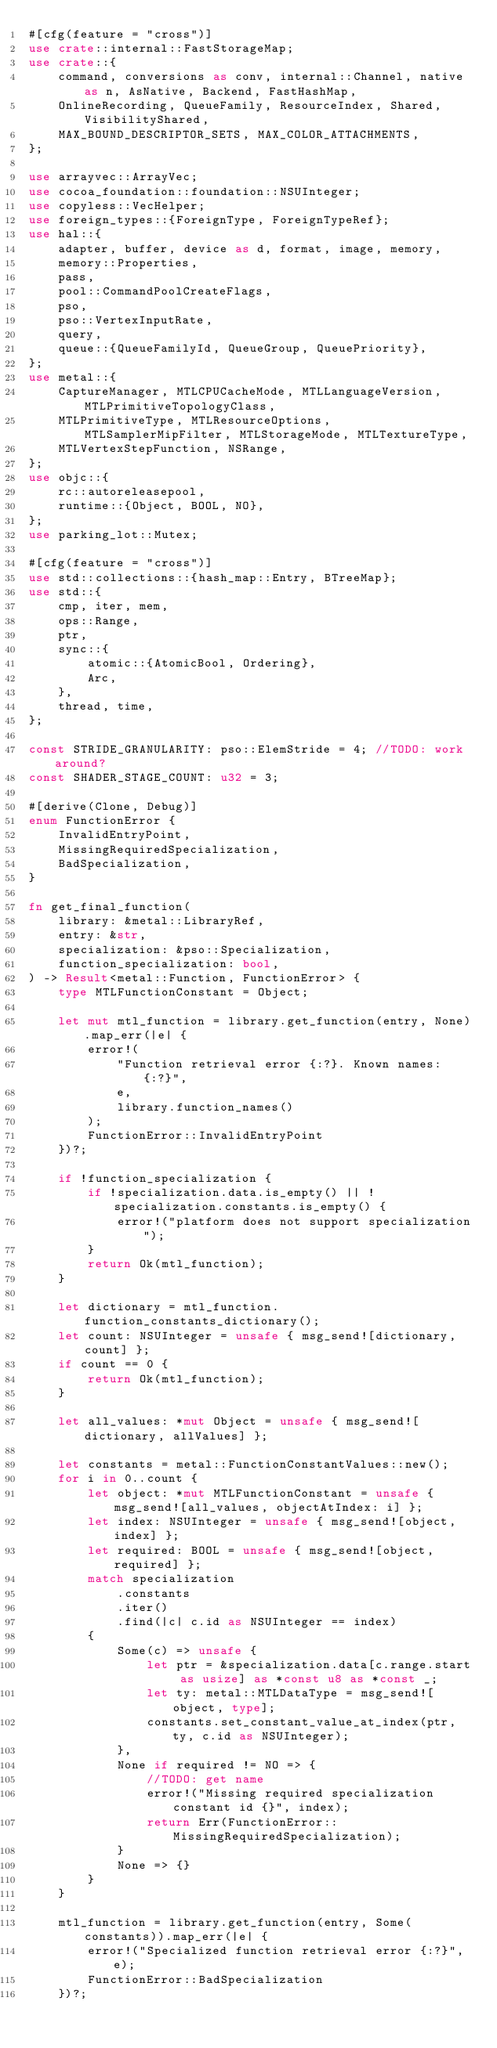<code> <loc_0><loc_0><loc_500><loc_500><_Rust_>#[cfg(feature = "cross")]
use crate::internal::FastStorageMap;
use crate::{
    command, conversions as conv, internal::Channel, native as n, AsNative, Backend, FastHashMap,
    OnlineRecording, QueueFamily, ResourceIndex, Shared, VisibilityShared,
    MAX_BOUND_DESCRIPTOR_SETS, MAX_COLOR_ATTACHMENTS,
};

use arrayvec::ArrayVec;
use cocoa_foundation::foundation::NSUInteger;
use copyless::VecHelper;
use foreign_types::{ForeignType, ForeignTypeRef};
use hal::{
    adapter, buffer, device as d, format, image, memory,
    memory::Properties,
    pass,
    pool::CommandPoolCreateFlags,
    pso,
    pso::VertexInputRate,
    query,
    queue::{QueueFamilyId, QueueGroup, QueuePriority},
};
use metal::{
    CaptureManager, MTLCPUCacheMode, MTLLanguageVersion, MTLPrimitiveTopologyClass,
    MTLPrimitiveType, MTLResourceOptions, MTLSamplerMipFilter, MTLStorageMode, MTLTextureType,
    MTLVertexStepFunction, NSRange,
};
use objc::{
    rc::autoreleasepool,
    runtime::{Object, BOOL, NO},
};
use parking_lot::Mutex;

#[cfg(feature = "cross")]
use std::collections::{hash_map::Entry, BTreeMap};
use std::{
    cmp, iter, mem,
    ops::Range,
    ptr,
    sync::{
        atomic::{AtomicBool, Ordering},
        Arc,
    },
    thread, time,
};

const STRIDE_GRANULARITY: pso::ElemStride = 4; //TODO: work around?
const SHADER_STAGE_COUNT: u32 = 3;

#[derive(Clone, Debug)]
enum FunctionError {
    InvalidEntryPoint,
    MissingRequiredSpecialization,
    BadSpecialization,
}

fn get_final_function(
    library: &metal::LibraryRef,
    entry: &str,
    specialization: &pso::Specialization,
    function_specialization: bool,
) -> Result<metal::Function, FunctionError> {
    type MTLFunctionConstant = Object;

    let mut mtl_function = library.get_function(entry, None).map_err(|e| {
        error!(
            "Function retrieval error {:?}. Known names: {:?}",
            e,
            library.function_names()
        );
        FunctionError::InvalidEntryPoint
    })?;

    if !function_specialization {
        if !specialization.data.is_empty() || !specialization.constants.is_empty() {
            error!("platform does not support specialization");
        }
        return Ok(mtl_function);
    }

    let dictionary = mtl_function.function_constants_dictionary();
    let count: NSUInteger = unsafe { msg_send![dictionary, count] };
    if count == 0 {
        return Ok(mtl_function);
    }

    let all_values: *mut Object = unsafe { msg_send![dictionary, allValues] };

    let constants = metal::FunctionConstantValues::new();
    for i in 0..count {
        let object: *mut MTLFunctionConstant = unsafe { msg_send![all_values, objectAtIndex: i] };
        let index: NSUInteger = unsafe { msg_send![object, index] };
        let required: BOOL = unsafe { msg_send![object, required] };
        match specialization
            .constants
            .iter()
            .find(|c| c.id as NSUInteger == index)
        {
            Some(c) => unsafe {
                let ptr = &specialization.data[c.range.start as usize] as *const u8 as *const _;
                let ty: metal::MTLDataType = msg_send![object, type];
                constants.set_constant_value_at_index(ptr, ty, c.id as NSUInteger);
            },
            None if required != NO => {
                //TODO: get name
                error!("Missing required specialization constant id {}", index);
                return Err(FunctionError::MissingRequiredSpecialization);
            }
            None => {}
        }
    }

    mtl_function = library.get_function(entry, Some(constants)).map_err(|e| {
        error!("Specialized function retrieval error {:?}", e);
        FunctionError::BadSpecialization
    })?;
</code> 